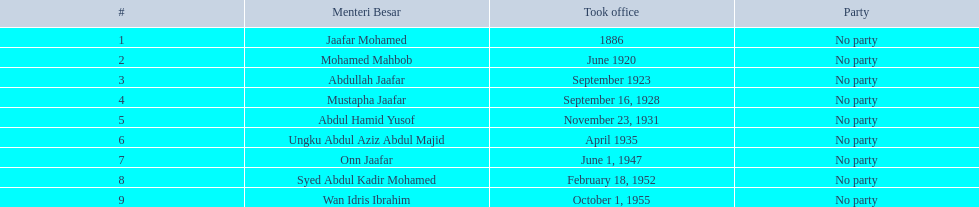Which menteri besars took office in the 1920's? Mohamed Mahbob, Abdullah Jaafar, Mustapha Jaafar. Of those men, who was only in office for 2 years? Mohamed Mahbob. 